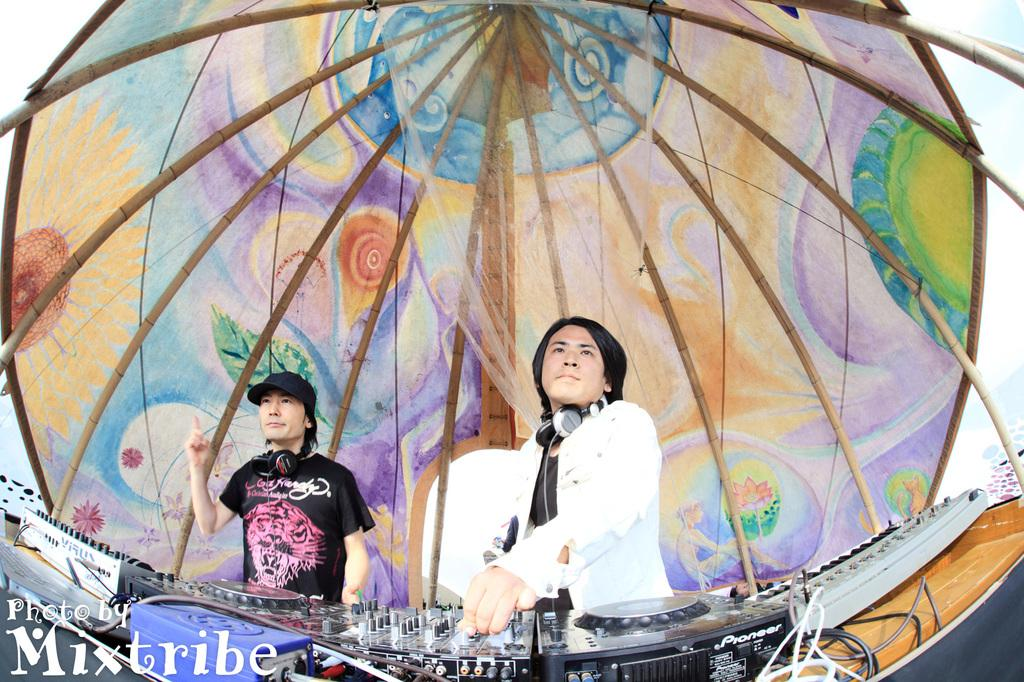What are the two persons in the image doing? The two persons in the image are controlling the DJs. Is there any text or logo visible in the image? Yes, there is a watermark in the bottom left-hand side of the image. What object can be seen at the top of the image? There appears to be an umbrella at the top of the image. What type of engine is visible in the image? There is no engine present in the image. What is the cause of the loss experienced by the persons in the image? There is no indication of loss or any negative experience in the image; the two persons are controlling the DJs. 